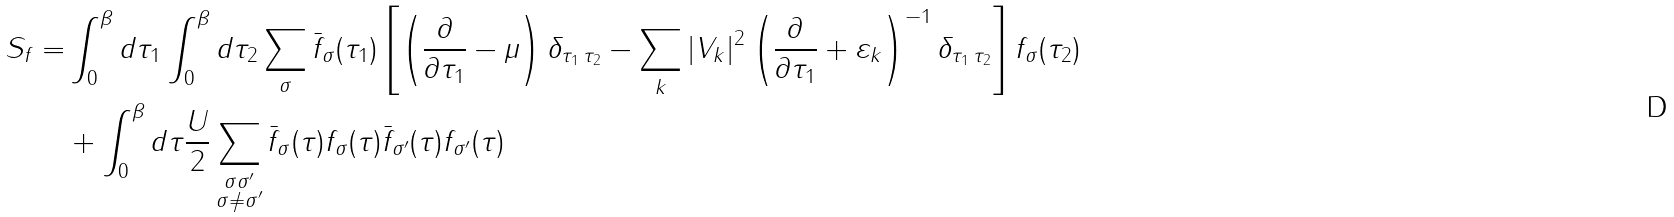<formula> <loc_0><loc_0><loc_500><loc_500>S _ { f } = & \int _ { 0 } ^ { \beta } d \tau _ { 1 } \int _ { 0 } ^ { \beta } d \tau _ { 2 } \sum _ { \sigma } \bar { f } _ { \sigma } ( \tau _ { 1 } ) \left [ \left ( \frac { \partial } { \partial \tau _ { 1 } } - \mu \right ) \delta _ { \tau _ { 1 } \, \tau _ { 2 } } - \sum _ { k } | V _ { k } | ^ { 2 } \left ( \frac { \partial } { \partial \tau _ { 1 } } + \varepsilon _ { k } \right ) ^ { - 1 } \delta _ { \tau _ { 1 } \, \tau _ { 2 } } \right ] f _ { \sigma } ( \tau _ { 2 } ) \\ & + \int _ { 0 } ^ { \beta } d \tau \frac { U } { 2 } \sum _ { \substack { \sigma \sigma ^ { \prime } \\ \sigma \neq \sigma ^ { \prime } } } \bar { f } _ { \sigma } ( \tau ) f _ { \sigma } ( \tau ) \bar { f } _ { \sigma ^ { \prime } } ( \tau ) f _ { \sigma ^ { \prime } } ( \tau )</formula> 